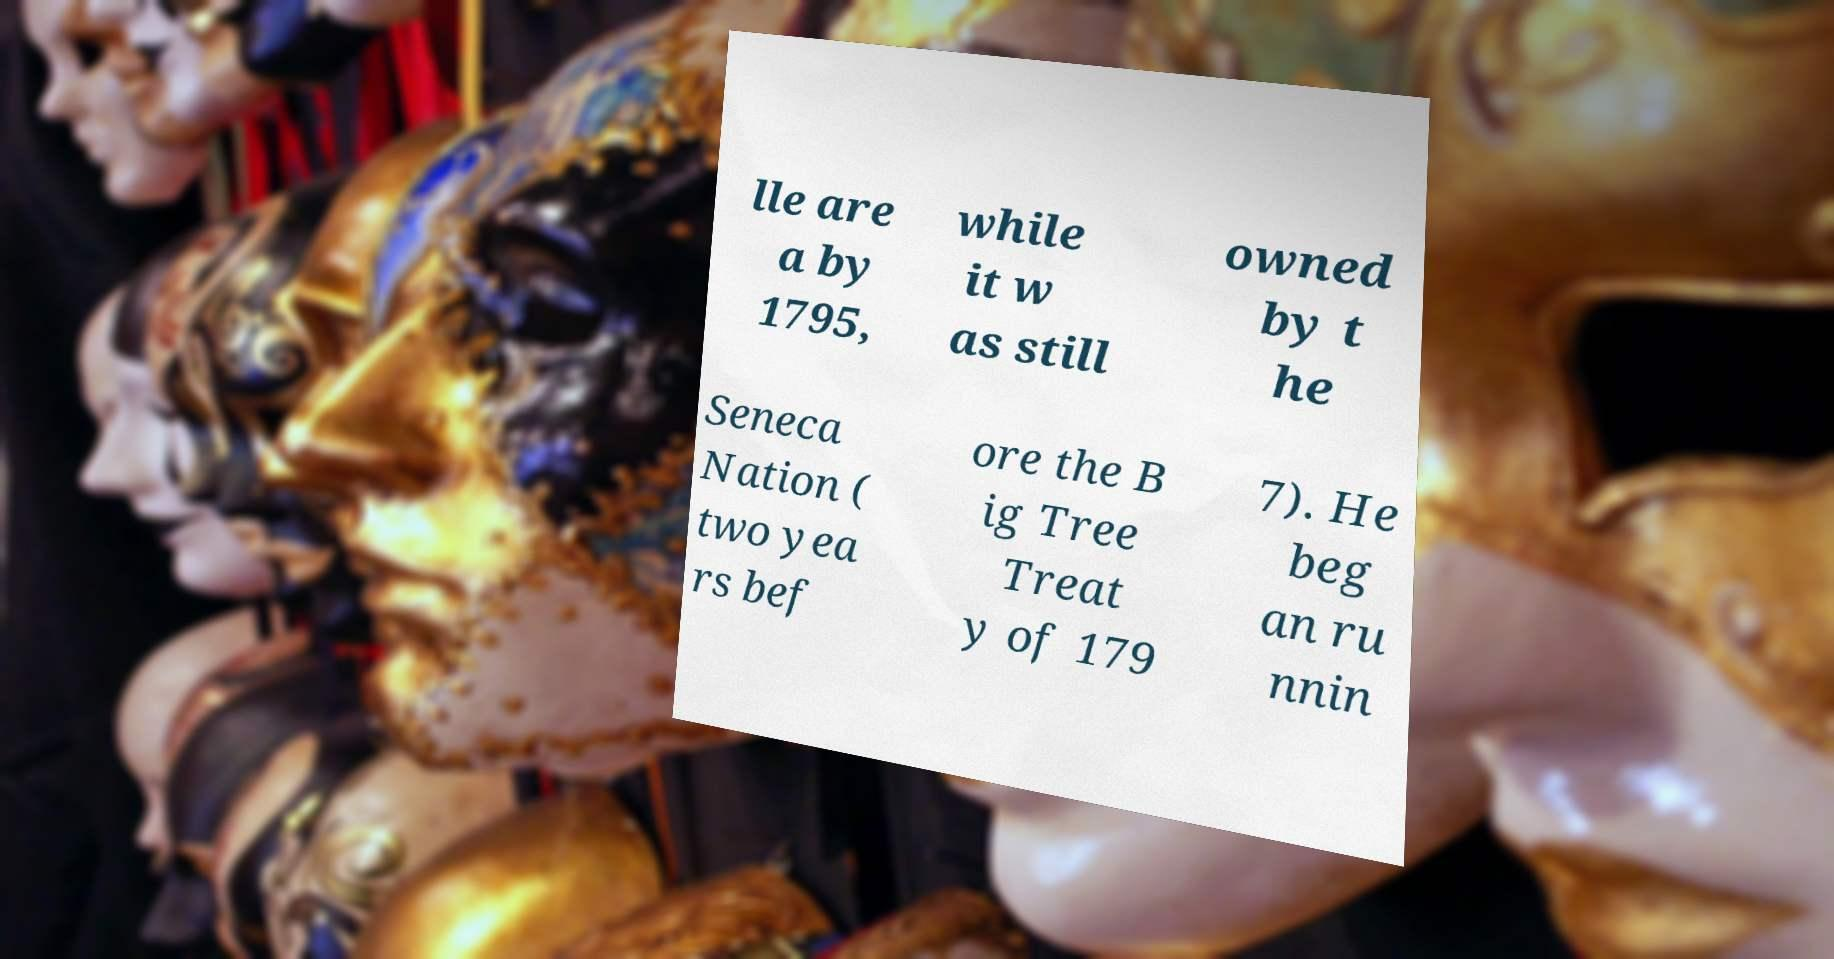Please read and relay the text visible in this image. What does it say? lle are a by 1795, while it w as still owned by t he Seneca Nation ( two yea rs bef ore the B ig Tree Treat y of 179 7). He beg an ru nnin 